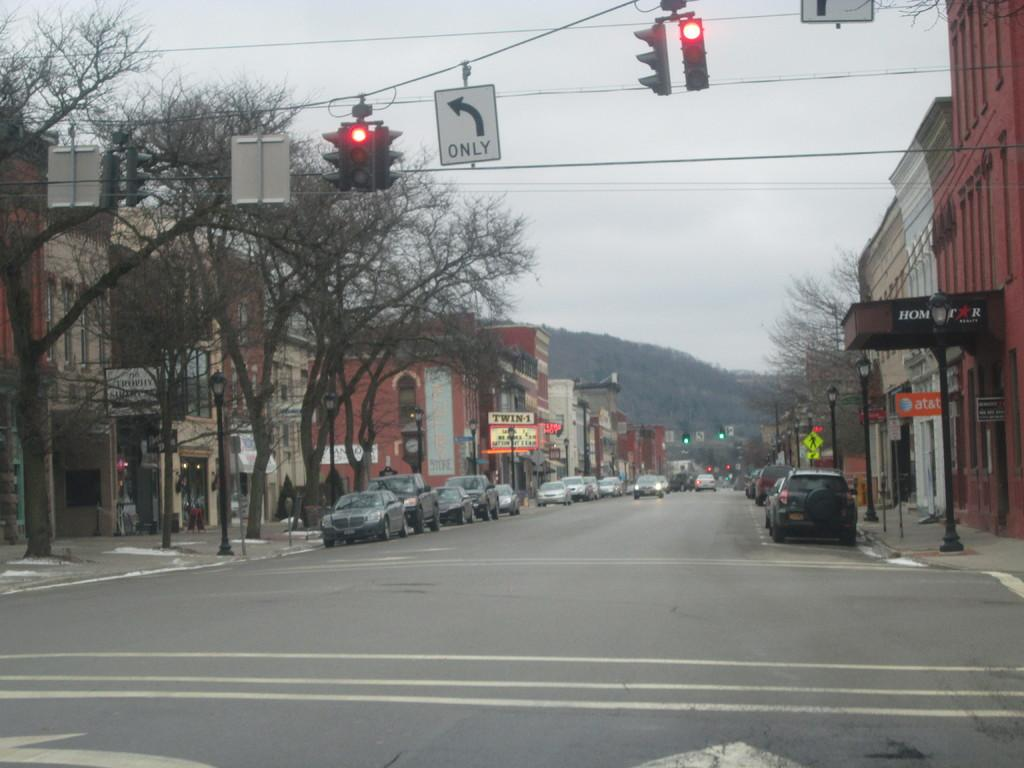<image>
Write a terse but informative summary of the picture. The next block contains an AT&T store on the right hand side. 